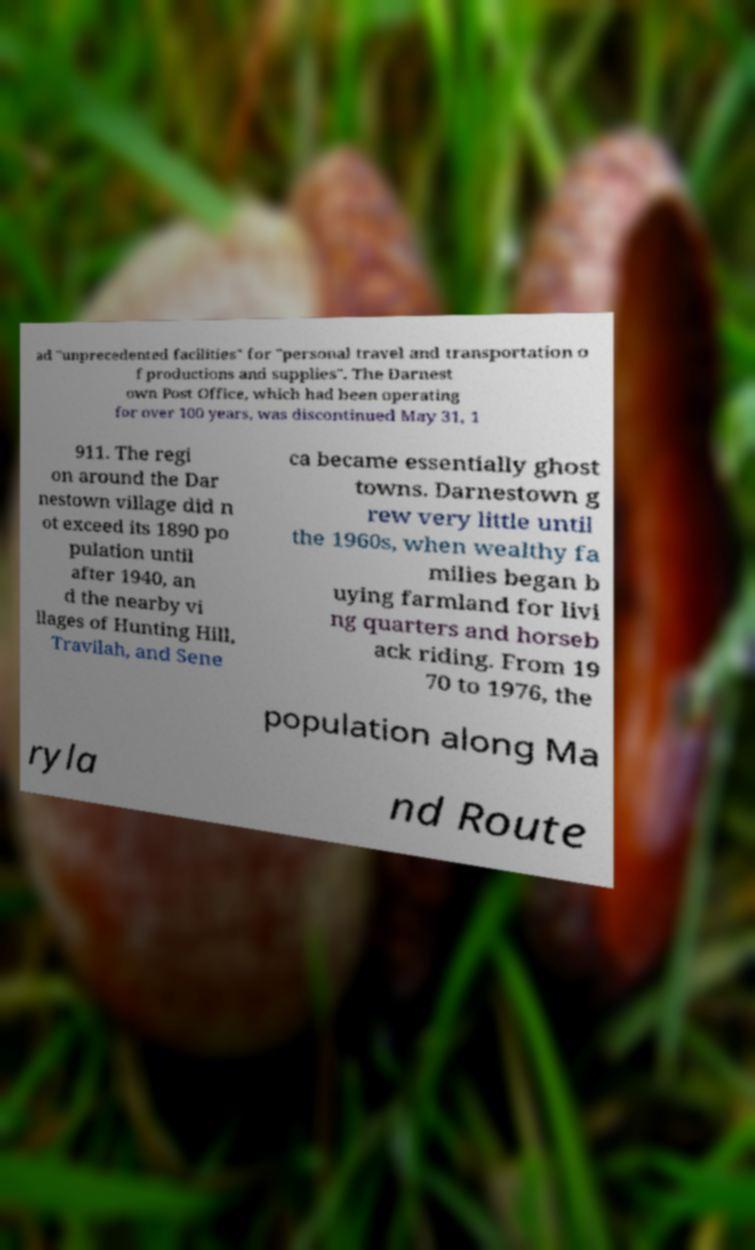Could you assist in decoding the text presented in this image and type it out clearly? ad "unprecedented facilities" for "personal travel and transportation o f productions and supplies". The Darnest own Post Office, which had been operating for over 100 years, was discontinued May 31, 1 911. The regi on around the Dar nestown village did n ot exceed its 1890 po pulation until after 1940, an d the nearby vi llages of Hunting Hill, Travilah, and Sene ca became essentially ghost towns. Darnestown g rew very little until the 1960s, when wealthy fa milies began b uying farmland for livi ng quarters and horseb ack riding. From 19 70 to 1976, the population along Ma ryla nd Route 